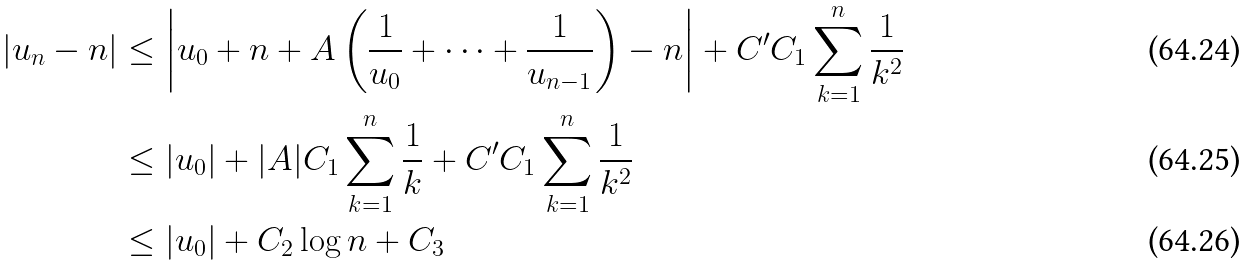<formula> <loc_0><loc_0><loc_500><loc_500>| u _ { n } - n | & \leq \left | u _ { 0 } + n + A \left ( \frac { 1 } { u _ { 0 } } + \dots + \frac { 1 } { u _ { n - 1 } } \right ) - n \right | + C ^ { \prime } C _ { 1 } \sum _ { k = 1 } ^ { n } \frac { 1 } { k ^ { 2 } } \\ & \leq | u _ { 0 } | + | A | C _ { 1 } \sum _ { k = 1 } ^ { n } \frac { 1 } { k } + C ^ { \prime } C _ { 1 } \sum _ { k = 1 } ^ { n } \frac { 1 } { k ^ { 2 } } \\ & \leq | u _ { 0 } | + C _ { 2 } \log n + C _ { 3 }</formula> 